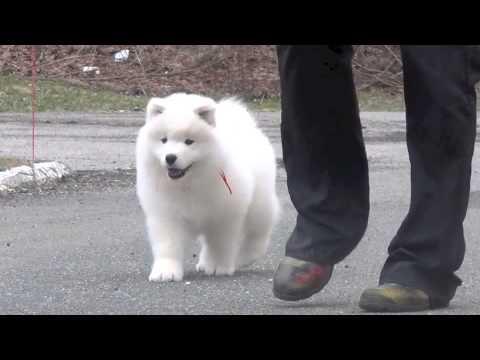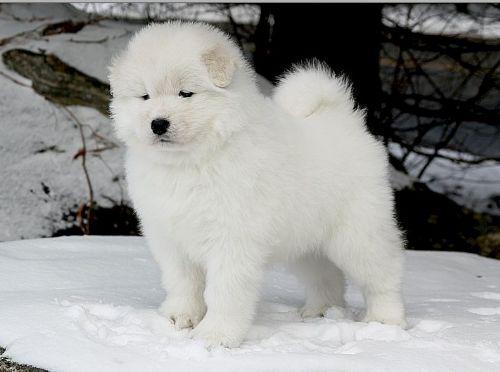The first image is the image on the left, the second image is the image on the right. Analyze the images presented: Is the assertion "An image features one white dog sleeping near one stuffed animal toy." valid? Answer yes or no. No. The first image is the image on the left, the second image is the image on the right. Considering the images on both sides, is "The right image contains at least three white dogs." valid? Answer yes or no. No. 